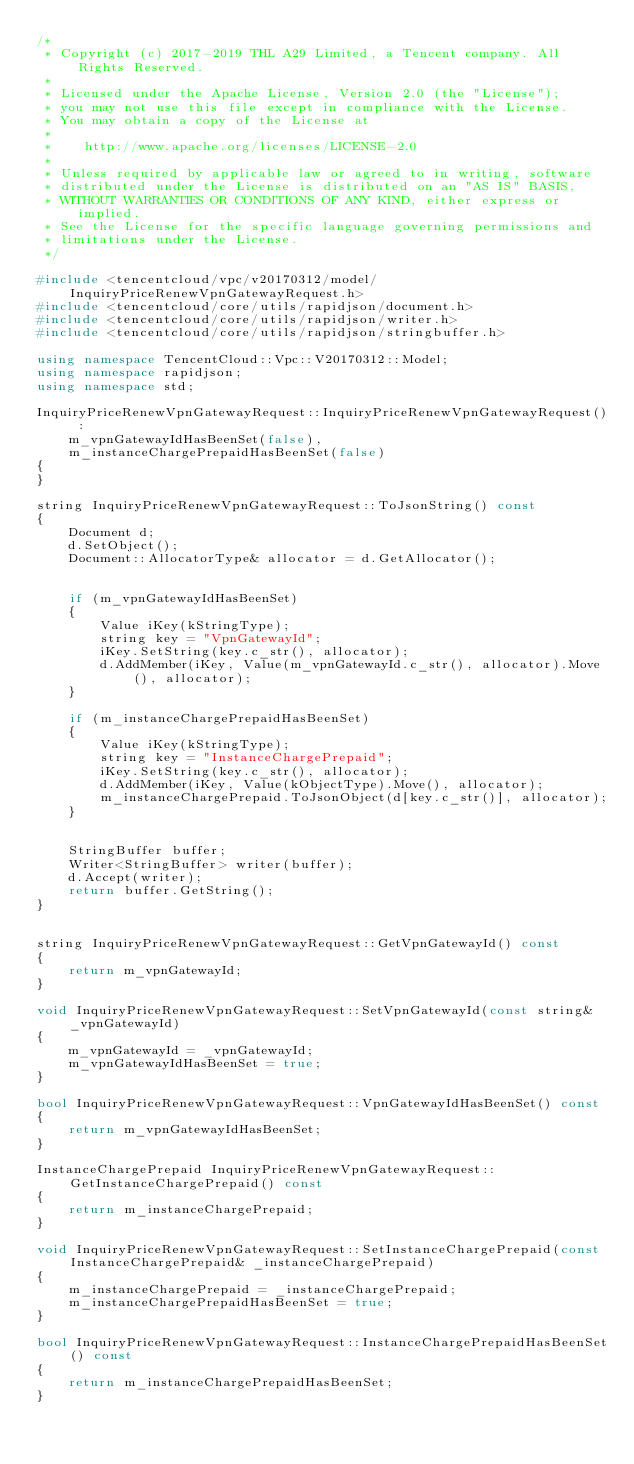Convert code to text. <code><loc_0><loc_0><loc_500><loc_500><_C++_>/*
 * Copyright (c) 2017-2019 THL A29 Limited, a Tencent company. All Rights Reserved.
 *
 * Licensed under the Apache License, Version 2.0 (the "License");
 * you may not use this file except in compliance with the License.
 * You may obtain a copy of the License at
 *
 *    http://www.apache.org/licenses/LICENSE-2.0
 *
 * Unless required by applicable law or agreed to in writing, software
 * distributed under the License is distributed on an "AS IS" BASIS,
 * WITHOUT WARRANTIES OR CONDITIONS OF ANY KIND, either express or implied.
 * See the License for the specific language governing permissions and
 * limitations under the License.
 */

#include <tencentcloud/vpc/v20170312/model/InquiryPriceRenewVpnGatewayRequest.h>
#include <tencentcloud/core/utils/rapidjson/document.h>
#include <tencentcloud/core/utils/rapidjson/writer.h>
#include <tencentcloud/core/utils/rapidjson/stringbuffer.h>

using namespace TencentCloud::Vpc::V20170312::Model;
using namespace rapidjson;
using namespace std;

InquiryPriceRenewVpnGatewayRequest::InquiryPriceRenewVpnGatewayRequest() :
    m_vpnGatewayIdHasBeenSet(false),
    m_instanceChargePrepaidHasBeenSet(false)
{
}

string InquiryPriceRenewVpnGatewayRequest::ToJsonString() const
{
    Document d;
    d.SetObject();
    Document::AllocatorType& allocator = d.GetAllocator();


    if (m_vpnGatewayIdHasBeenSet)
    {
        Value iKey(kStringType);
        string key = "VpnGatewayId";
        iKey.SetString(key.c_str(), allocator);
        d.AddMember(iKey, Value(m_vpnGatewayId.c_str(), allocator).Move(), allocator);
    }

    if (m_instanceChargePrepaidHasBeenSet)
    {
        Value iKey(kStringType);
        string key = "InstanceChargePrepaid";
        iKey.SetString(key.c_str(), allocator);
        d.AddMember(iKey, Value(kObjectType).Move(), allocator);
        m_instanceChargePrepaid.ToJsonObject(d[key.c_str()], allocator);
    }


    StringBuffer buffer;
    Writer<StringBuffer> writer(buffer);
    d.Accept(writer);
    return buffer.GetString();
}


string InquiryPriceRenewVpnGatewayRequest::GetVpnGatewayId() const
{
    return m_vpnGatewayId;
}

void InquiryPriceRenewVpnGatewayRequest::SetVpnGatewayId(const string& _vpnGatewayId)
{
    m_vpnGatewayId = _vpnGatewayId;
    m_vpnGatewayIdHasBeenSet = true;
}

bool InquiryPriceRenewVpnGatewayRequest::VpnGatewayIdHasBeenSet() const
{
    return m_vpnGatewayIdHasBeenSet;
}

InstanceChargePrepaid InquiryPriceRenewVpnGatewayRequest::GetInstanceChargePrepaid() const
{
    return m_instanceChargePrepaid;
}

void InquiryPriceRenewVpnGatewayRequest::SetInstanceChargePrepaid(const InstanceChargePrepaid& _instanceChargePrepaid)
{
    m_instanceChargePrepaid = _instanceChargePrepaid;
    m_instanceChargePrepaidHasBeenSet = true;
}

bool InquiryPriceRenewVpnGatewayRequest::InstanceChargePrepaidHasBeenSet() const
{
    return m_instanceChargePrepaidHasBeenSet;
}


</code> 